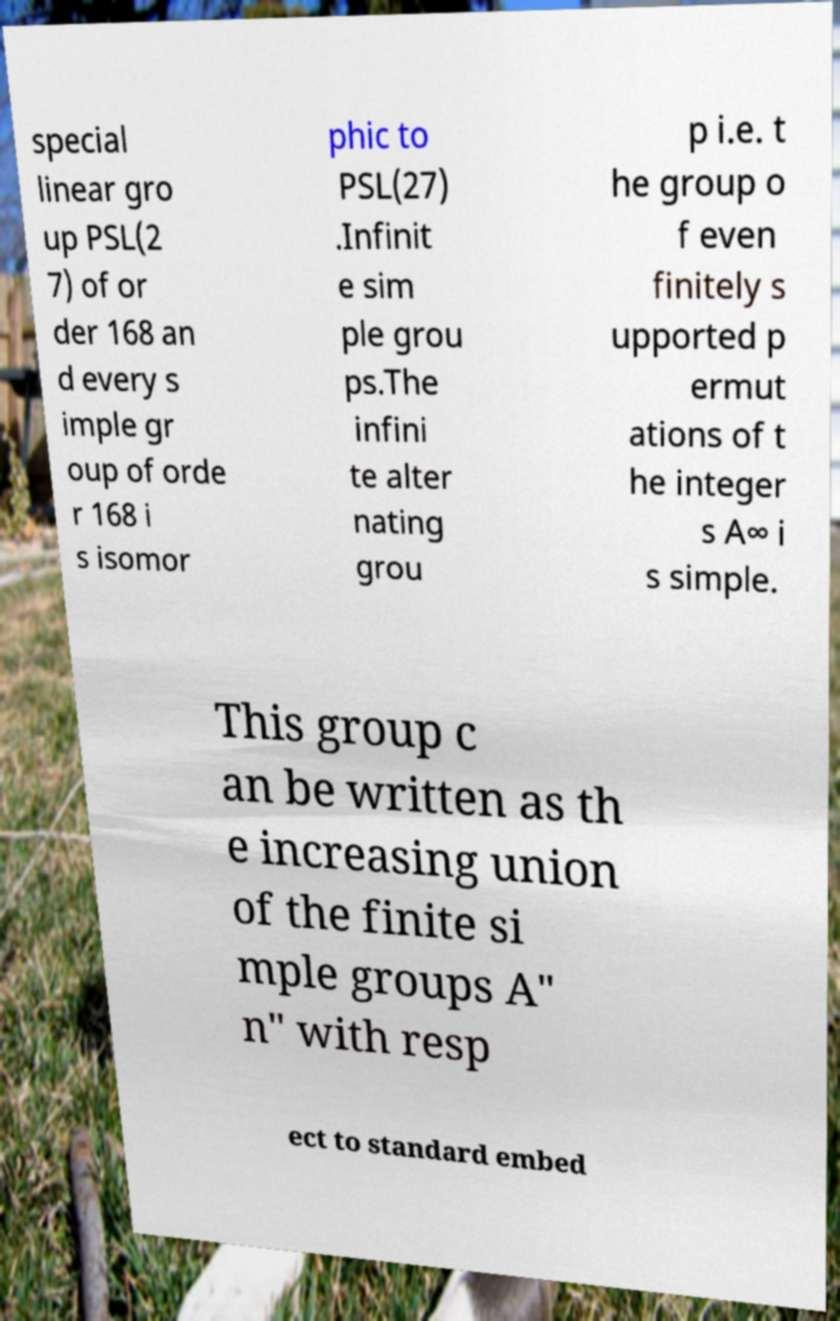Could you extract and type out the text from this image? special linear gro up PSL(2 7) of or der 168 an d every s imple gr oup of orde r 168 i s isomor phic to PSL(27) .Infinit e sim ple grou ps.The infini te alter nating grou p i.e. t he group o f even finitely s upported p ermut ations of t he integer s A∞ i s simple. This group c an be written as th e increasing union of the finite si mple groups A" n" with resp ect to standard embed 